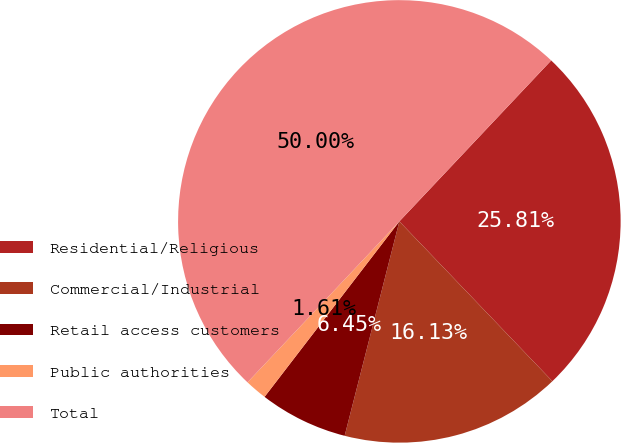Convert chart to OTSL. <chart><loc_0><loc_0><loc_500><loc_500><pie_chart><fcel>Residential/Religious<fcel>Commercial/Industrial<fcel>Retail access customers<fcel>Public authorities<fcel>Total<nl><fcel>25.81%<fcel>16.13%<fcel>6.45%<fcel>1.61%<fcel>50.0%<nl></chart> 